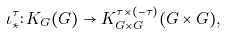Convert formula to latex. <formula><loc_0><loc_0><loc_500><loc_500>\iota ^ { \tau } _ { * } \colon K _ { G } ( G ) \to K ^ { \tau \times ( - \tau ) } _ { G \times G } ( G \times G ) ,</formula> 